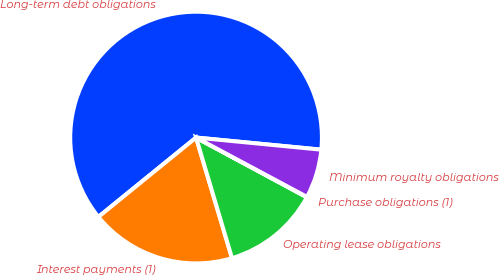<chart> <loc_0><loc_0><loc_500><loc_500><pie_chart><fcel>Long-term debt obligations<fcel>Interest payments (1)<fcel>Operating lease obligations<fcel>Purchase obligations (1)<fcel>Minimum royalty obligations<nl><fcel>62.39%<fcel>18.75%<fcel>12.52%<fcel>0.05%<fcel>6.28%<nl></chart> 